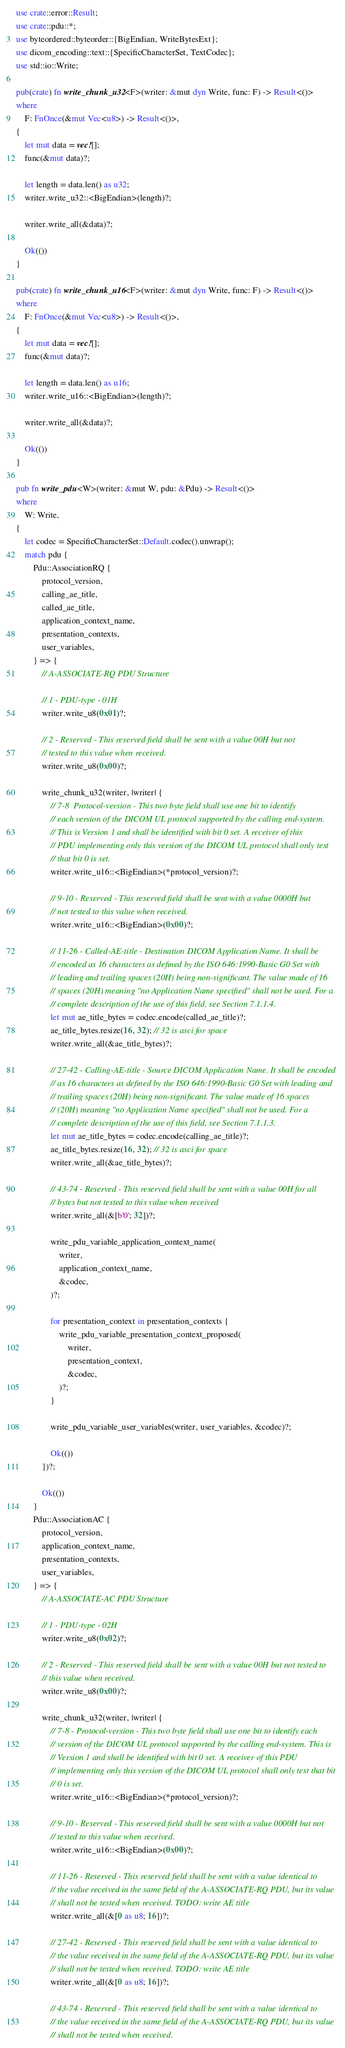Convert code to text. <code><loc_0><loc_0><loc_500><loc_500><_Rust_>use crate::error::Result;
use crate::pdu::*;
use byteordered::byteorder::{BigEndian, WriteBytesExt};
use dicom_encoding::text::{SpecificCharacterSet, TextCodec};
use std::io::Write;

pub(crate) fn write_chunk_u32<F>(writer: &mut dyn Write, func: F) -> Result<()>
where
    F: FnOnce(&mut Vec<u8>) -> Result<()>,
{
    let mut data = vec![];
    func(&mut data)?;

    let length = data.len() as u32;
    writer.write_u32::<BigEndian>(length)?;

    writer.write_all(&data)?;

    Ok(())
}

pub(crate) fn write_chunk_u16<F>(writer: &mut dyn Write, func: F) -> Result<()>
where
    F: FnOnce(&mut Vec<u8>) -> Result<()>,
{
    let mut data = vec![];
    func(&mut data)?;

    let length = data.len() as u16;
    writer.write_u16::<BigEndian>(length)?;

    writer.write_all(&data)?;

    Ok(())
}

pub fn write_pdu<W>(writer: &mut W, pdu: &Pdu) -> Result<()>
where
    W: Write,
{
    let codec = SpecificCharacterSet::Default.codec().unwrap();
    match pdu {
        Pdu::AssociationRQ {
            protocol_version,
            calling_ae_title,
            called_ae_title,
            application_context_name,
            presentation_contexts,
            user_variables,
        } => {
            // A-ASSOCIATE-RQ PDU Structure

            // 1 - PDU-type - 01H
            writer.write_u8(0x01)?;

            // 2 - Reserved - This reserved field shall be sent with a value 00H but not
            // tested to this value when received.
            writer.write_u8(0x00)?;

            write_chunk_u32(writer, |writer| {
                // 7-8  Protocol-version - This two byte field shall use one bit to identify
                // each version of the DICOM UL protocol supported by the calling end-system.
                // This is Version 1 and shall be identified with bit 0 set. A receiver of this
                // PDU implementing only this version of the DICOM UL protocol shall only test
                // that bit 0 is set.
                writer.write_u16::<BigEndian>(*protocol_version)?;

                // 9-10 - Reserved - This reserved field shall be sent with a value 0000H but
                // not tested to this value when received.
                writer.write_u16::<BigEndian>(0x00)?;

                // 11-26 - Called-AE-title - Destination DICOM Application Name. It shall be
                // encoded as 16 characters as defined by the ISO 646:1990-Basic G0 Set with
                // leading and trailing spaces (20H) being non-significant. The value made of 16
                // spaces (20H) meaning "no Application Name specified" shall not be used. For a
                // complete description of the use of this field, see Section 7.1.1.4.
                let mut ae_title_bytes = codec.encode(called_ae_title)?;
                ae_title_bytes.resize(16, 32); // 32 is asci for space
                writer.write_all(&ae_title_bytes)?;

                // 27-42 - Calling-AE-title - Source DICOM Application Name. It shall be encoded
                // as 16 characters as defined by the ISO 646:1990-Basic G0 Set with leading and
                // trailing spaces (20H) being non-significant. The value made of 16 spaces
                // (20H) meaning "no Application Name specified" shall not be used. For a
                // complete description of the use of this field, see Section 7.1.1.3.
                let mut ae_title_bytes = codec.encode(calling_ae_title)?;
                ae_title_bytes.resize(16, 32); // 32 is asci for space
                writer.write_all(&ae_title_bytes)?;

                // 43-74 - Reserved - This reserved field shall be sent with a value 00H for all
                // bytes but not tested to this value when received
                writer.write_all(&[b'0'; 32])?;

                write_pdu_variable_application_context_name(
                    writer,
                    application_context_name,
                    &codec,
                )?;

                for presentation_context in presentation_contexts {
                    write_pdu_variable_presentation_context_proposed(
                        writer,
                        presentation_context,
                        &codec,
                    )?;
                }

                write_pdu_variable_user_variables(writer, user_variables, &codec)?;

                Ok(())
            })?;

            Ok(())
        }
        Pdu::AssociationAC {
            protocol_version,
            application_context_name,
            presentation_contexts,
            user_variables,
        } => {
            // A-ASSOCIATE-AC PDU Structure

            // 1 - PDU-type - 02H
            writer.write_u8(0x02)?;

            // 2 - Reserved - This reserved field shall be sent with a value 00H but not tested to
            // this value when received.
            writer.write_u8(0x00)?;

            write_chunk_u32(writer, |writer| {
                // 7-8 - Protocol-version - This two byte field shall use one bit to identify each
                // version of the DICOM UL protocol supported by the calling end-system. This is
                // Version 1 and shall be identified with bit 0 set. A receiver of this PDU
                // implementing only this version of the DICOM UL protocol shall only test that bit
                // 0 is set.
                writer.write_u16::<BigEndian>(*protocol_version)?;

                // 9-10 - Reserved - This reserved field shall be sent with a value 0000H but not
                // tested to this value when received.
                writer.write_u16::<BigEndian>(0x00)?;

                // 11-26 - Reserved - This reserved field shall be sent with a value identical to
                // the value received in the same field of the A-ASSOCIATE-RQ PDU, but its value
                // shall not be tested when received. TODO: write AE title
                writer.write_all(&[0 as u8; 16])?;

                // 27-42 - Reserved - This reserved field shall be sent with a value identical to
                // the value received in the same field of the A-ASSOCIATE-RQ PDU, but its value
                // shall not be tested when received. TODO: write AE title
                writer.write_all(&[0 as u8; 16])?;

                // 43-74 - Reserved - This reserved field shall be sent with a value identical to
                // the value received in the same field of the A-ASSOCIATE-RQ PDU, but its value
                // shall not be tested when received.</code> 